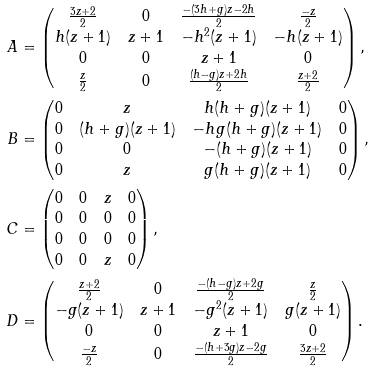<formula> <loc_0><loc_0><loc_500><loc_500>A & = \begin{pmatrix} \frac { 3 z + 2 } { 2 } & 0 & \frac { - ( 3 h + g ) z - 2 h } { 2 } & \frac { - z } { 2 } \\ h ( z + 1 ) & z + 1 & - h ^ { 2 } ( z + 1 ) & - h ( z + 1 ) \\ 0 & 0 & z + 1 & 0 \\ \frac { z } { 2 } & 0 & \frac { ( h - g ) z + 2 h } { 2 } & \frac { z + 2 } { 2 } \end{pmatrix} , \\ B & = \begin{pmatrix} 0 & z & h ( h + g ) ( z + 1 ) & 0 \\ 0 & ( h + g ) ( z + 1 ) & - h g ( h + g ) ( z + 1 ) & 0 \\ 0 & 0 & - ( h + g ) ( z + 1 ) & 0 \\ 0 & z & g ( h + g ) ( z + 1 ) & 0 \end{pmatrix} , \\ C & = \begin{pmatrix} 0 & 0 & z & 0 \\ 0 & 0 & 0 & 0 \\ 0 & 0 & 0 & 0 \\ 0 & 0 & z & 0 \end{pmatrix} , \\ D & = \begin{pmatrix} \frac { z + 2 } { 2 } & 0 & \frac { - ( h - g ) z + 2 g } { 2 } & \frac { z } { 2 } \\ - g ( z + 1 ) & z + 1 & - g ^ { 2 } ( z + 1 ) & g ( z + 1 ) \\ 0 & 0 & z + 1 & 0 \\ \frac { - z } { 2 } & 0 & \frac { - ( h + 3 g ) z - 2 g } { 2 } & \frac { 3 z + 2 } { 2 } \end{pmatrix} .</formula> 